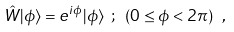Convert formula to latex. <formula><loc_0><loc_0><loc_500><loc_500>\hat { W } | \phi \rangle = e ^ { i \phi } | \phi \rangle \ ; \ \left ( 0 \leq \phi < 2 \pi \right ) \ ,</formula> 